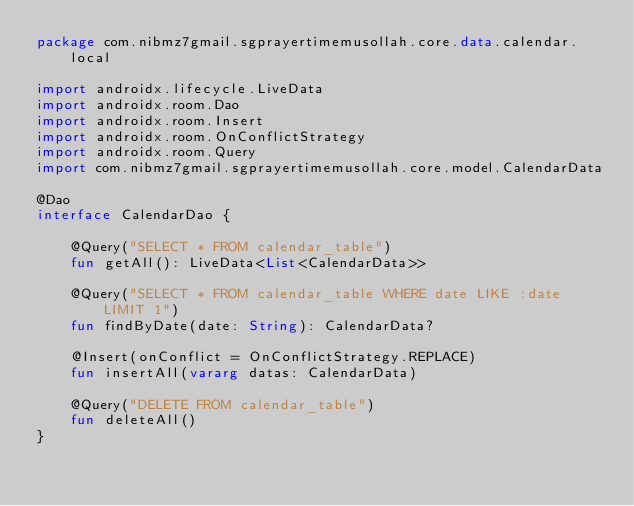Convert code to text. <code><loc_0><loc_0><loc_500><loc_500><_Kotlin_>package com.nibmz7gmail.sgprayertimemusollah.core.data.calendar.local

import androidx.lifecycle.LiveData
import androidx.room.Dao
import androidx.room.Insert
import androidx.room.OnConflictStrategy
import androidx.room.Query
import com.nibmz7gmail.sgprayertimemusollah.core.model.CalendarData

@Dao
interface CalendarDao {

    @Query("SELECT * FROM calendar_table")
    fun getAll(): LiveData<List<CalendarData>>

    @Query("SELECT * FROM calendar_table WHERE date LIKE :date LIMIT 1")
    fun findByDate(date: String): CalendarData?

    @Insert(onConflict = OnConflictStrategy.REPLACE)
    fun insertAll(vararg datas: CalendarData)

    @Query("DELETE FROM calendar_table")
    fun deleteAll()
}</code> 